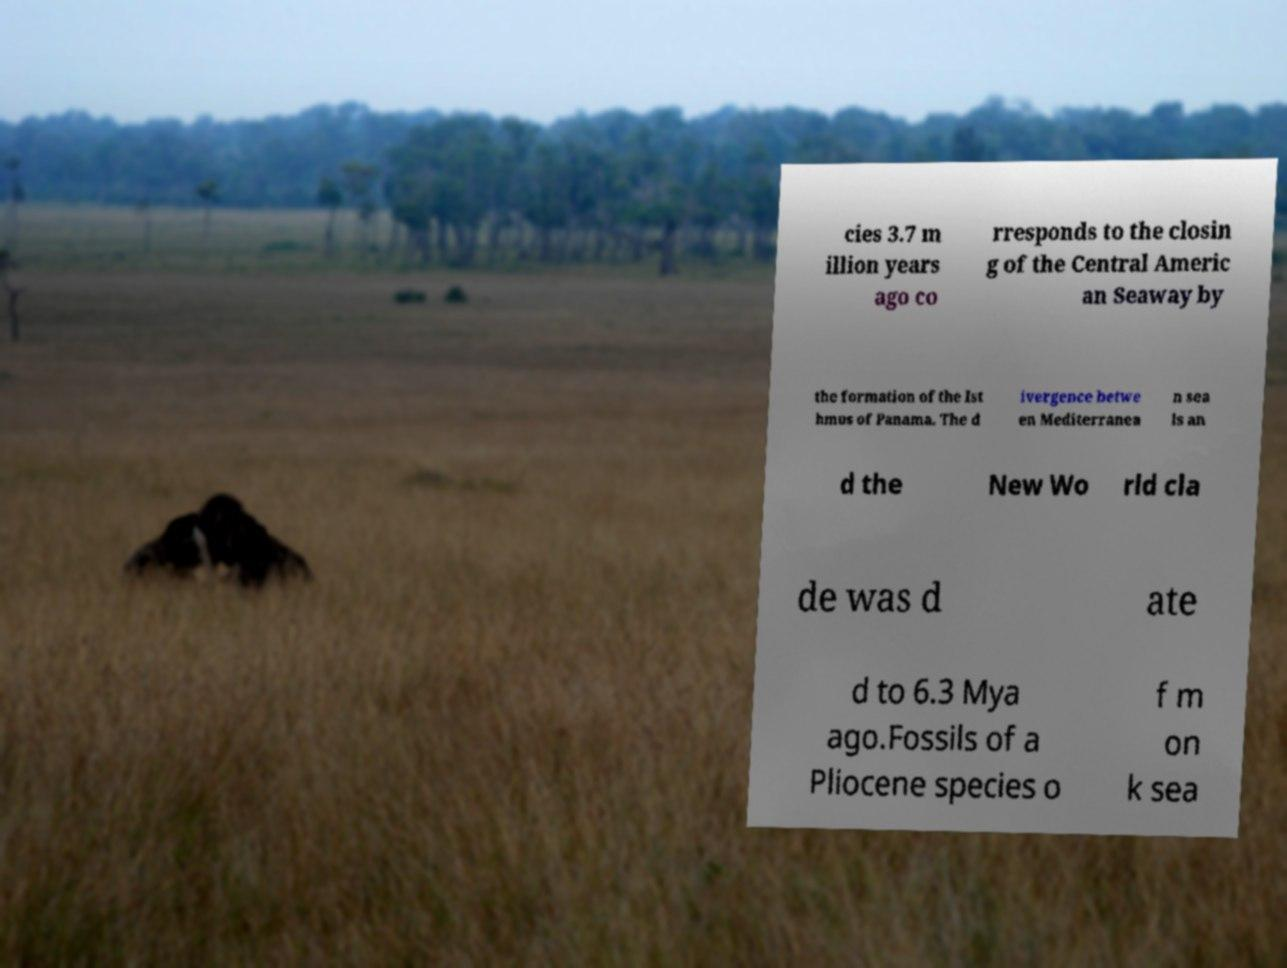Please identify and transcribe the text found in this image. cies 3.7 m illion years ago co rresponds to the closin g of the Central Americ an Seaway by the formation of the Ist hmus of Panama. The d ivergence betwe en Mediterranea n sea ls an d the New Wo rld cla de was d ate d to 6.3 Mya ago.Fossils of a Pliocene species o f m on k sea 